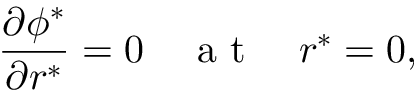<formula> <loc_0><loc_0><loc_500><loc_500>\frac { \partial \phi ^ { * } } { \partial r ^ { * } } = 0 \quad a t \quad r ^ { * } = 0 ,</formula> 